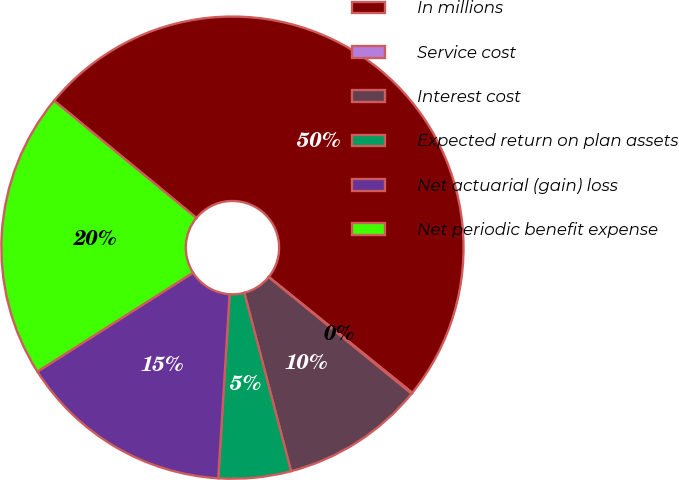Convert chart. <chart><loc_0><loc_0><loc_500><loc_500><pie_chart><fcel>In millions<fcel>Service cost<fcel>Interest cost<fcel>Expected return on plan assets<fcel>Net actuarial (gain) loss<fcel>Net periodic benefit expense<nl><fcel>49.84%<fcel>0.08%<fcel>10.03%<fcel>5.06%<fcel>15.01%<fcel>19.98%<nl></chart> 